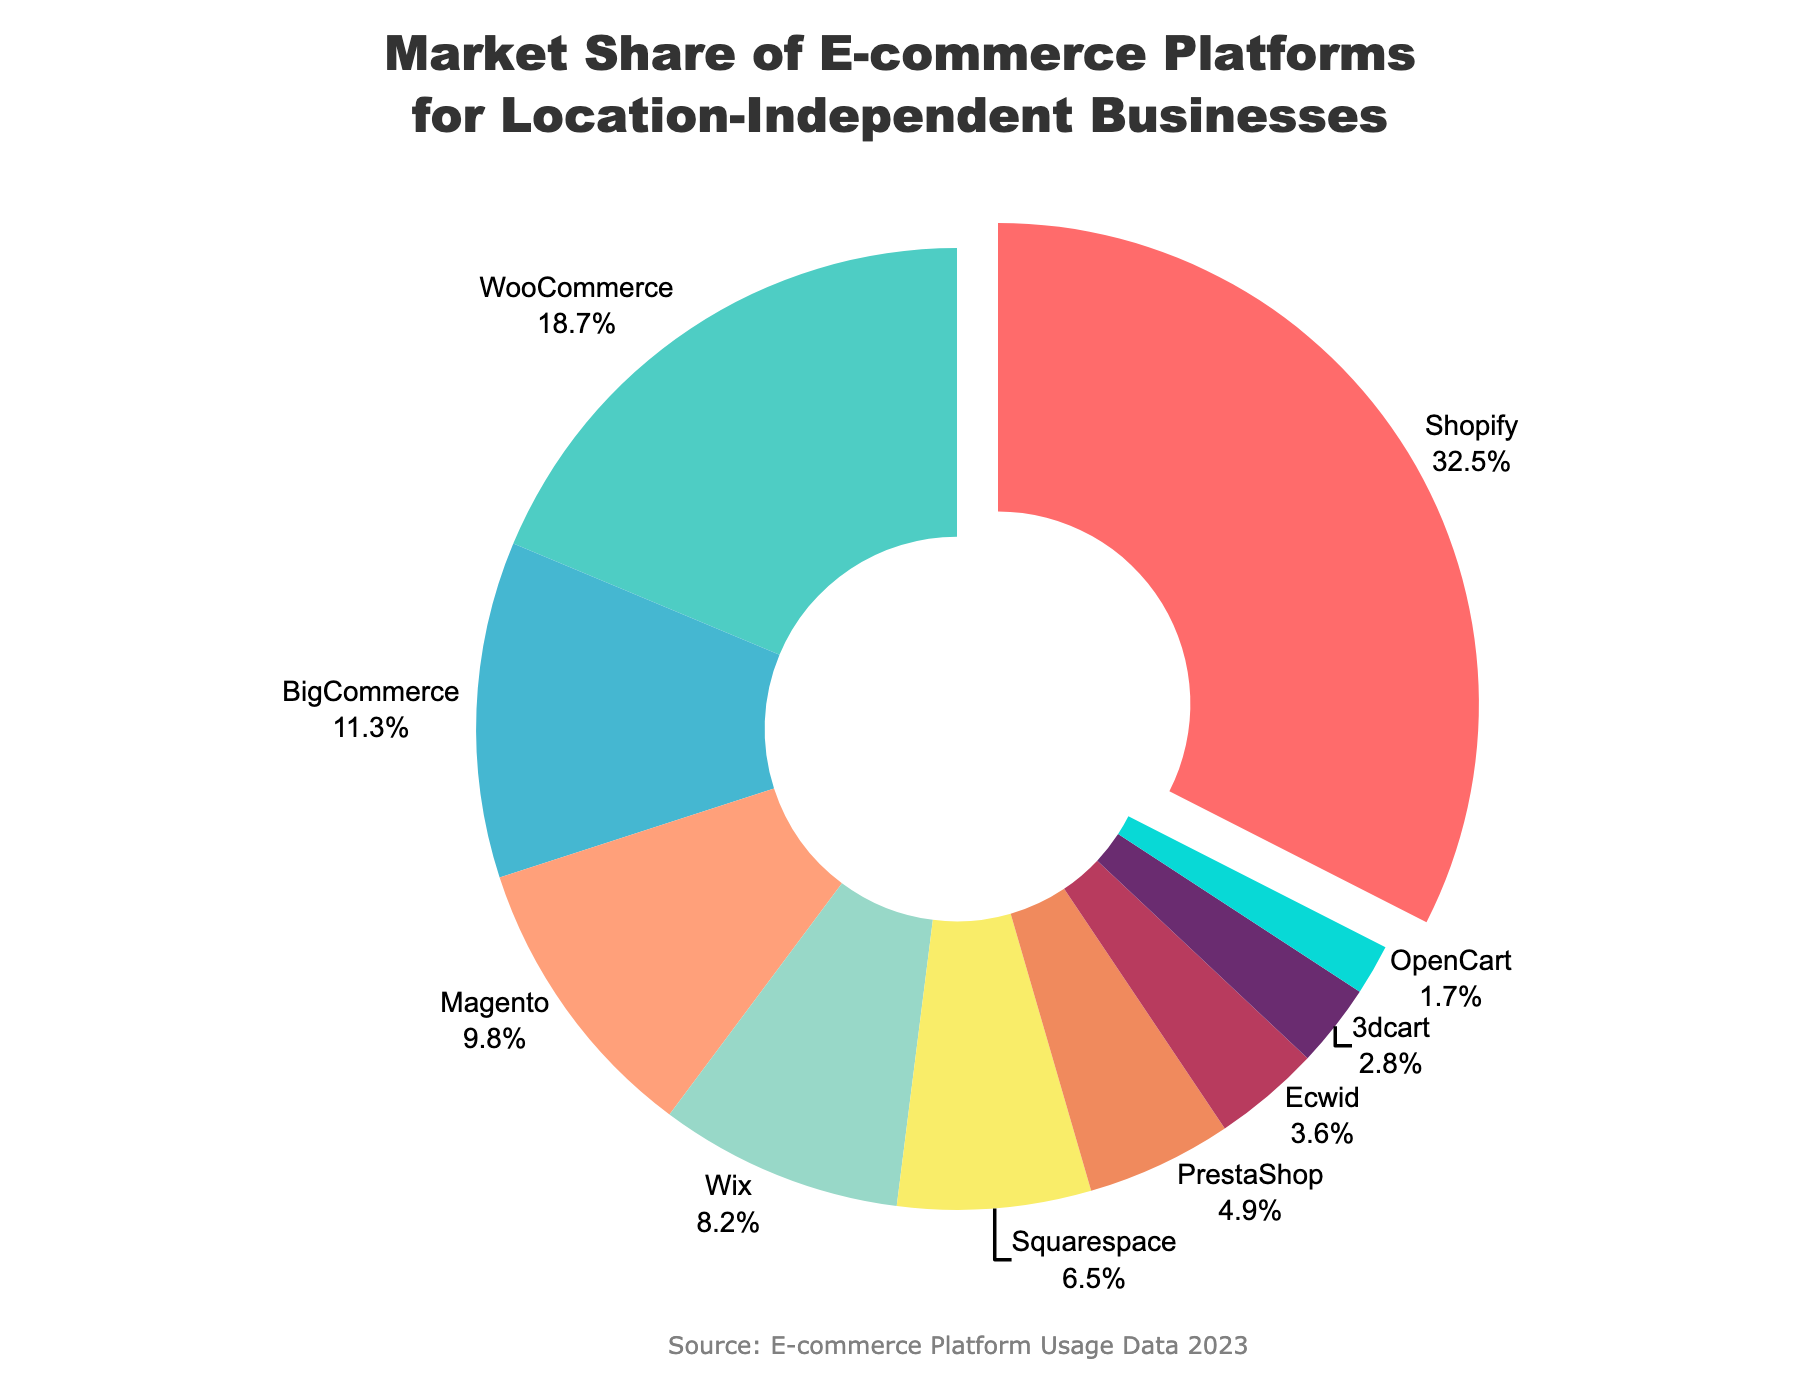Which platform holds the largest market share? The platform with the highest percentage value in the pie chart is Shopify, as indicated by the largest sector size and the highest percentage displayed.
Answer: Shopify Which platforms have a market share greater than 10%? By examining the percentage values on the pie chart, the platforms with a market share greater than 10% are Shopify, WooCommerce, and BigCommerce.
Answer: Shopify, WooCommerce, BigCommerce What is the combined market share of Wix and Squarespace? Add the market shares of Wix (8.2%) and Squarespace (6.5%) to get the total combined market share. 8.2% + 6.5% = 14.7%
Answer: 14.7% How much more market share does Shopify have compared to Magento? Subtract Magento's market share (9.8%) from Shopify's market share (32.5%) to get the difference. 32.5% - 9.8% = 22.7%
Answer: 22.7% Which platform has the smallest market share and what is its value? The platform with the smallest sector and the lowest percentage value displayed in the pie chart is OpenCart with 1.7% market share.
Answer: OpenCart, 1.7% Between Ecwid and 3dcart, which has a higher market share and by how much? Compare the market shares of Ecwid (3.6%) and 3dcart (2.8%). Ecwid has a higher market share by 3.6% - 2.8% = 0.8%.
Answer: Ecwid, 0.8% How does the total market share of platforms with less than 5% compare to that of WooCommerce? Calculate the sum of market shares of platforms with less than 5%: PrestaShop (4.9%) + Ecwid (3.6%) + 3dcart (2.8%) + OpenCart (1.7%) = 13%. WooCommerce's market share is 18.7%. WooCommerce has a greater market share than the total of those platforms combined.
Answer: WooCommerce > Sum Identify the platforms with market shares represented in shades of blue. The platforms represented with blue shades in the chart are BigCommerce (11.3%), Wix (8.2%), and OpenCart (1.7%). These are identified by their corresponding pie segments in blue colors.
Answer: BigCommerce, Wix, OpenCart 